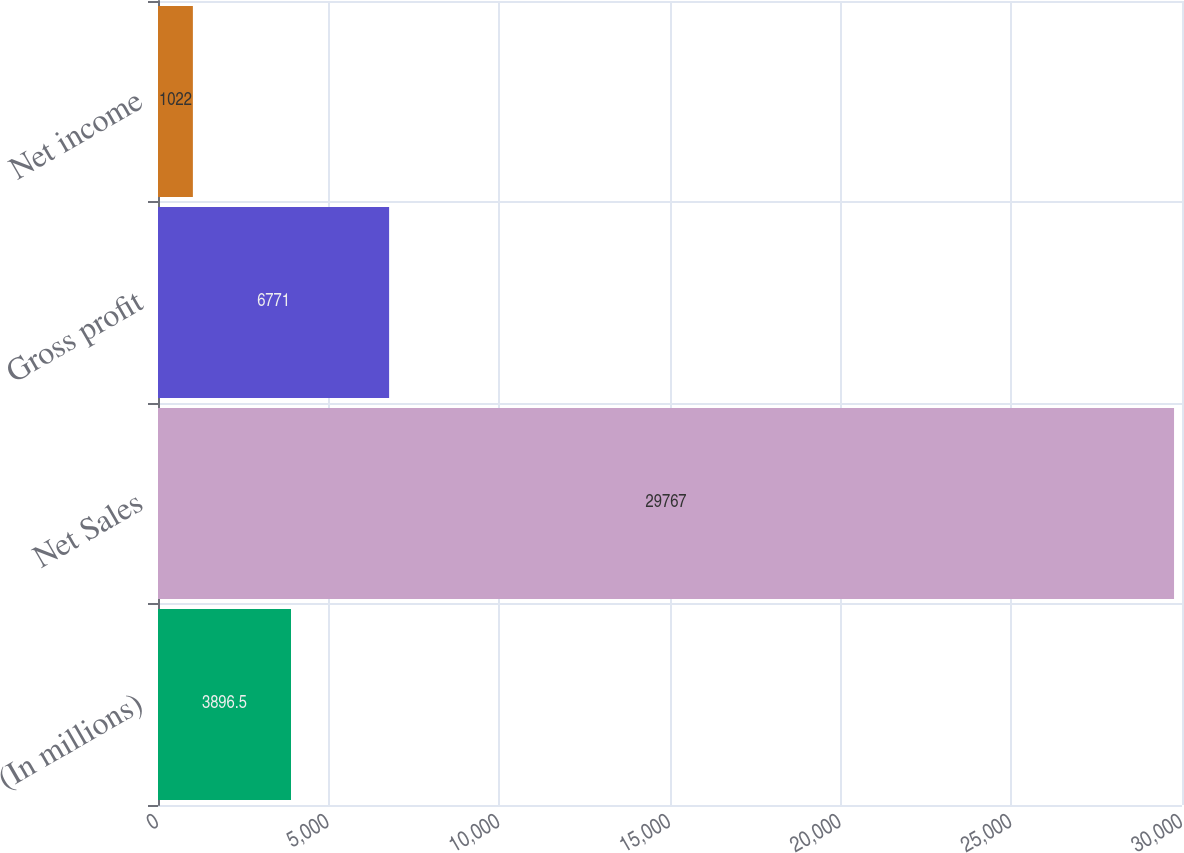Convert chart. <chart><loc_0><loc_0><loc_500><loc_500><bar_chart><fcel>(In millions)<fcel>Net Sales<fcel>Gross profit<fcel>Net income<nl><fcel>3896.5<fcel>29767<fcel>6771<fcel>1022<nl></chart> 